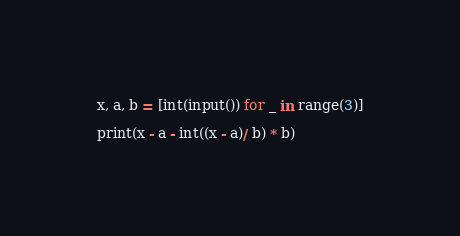<code> <loc_0><loc_0><loc_500><loc_500><_Python_>x, a, b = [int(input()) for _ in range(3)]

print(x - a - int((x - a)/ b) * b)</code> 